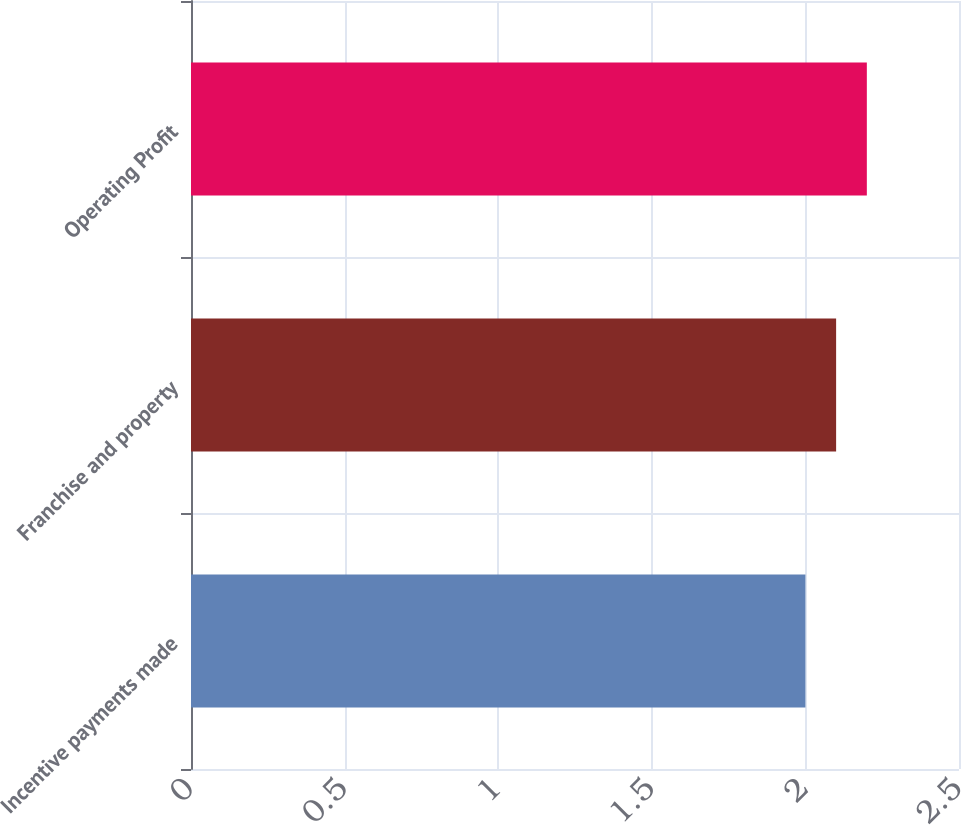Convert chart. <chart><loc_0><loc_0><loc_500><loc_500><bar_chart><fcel>Incentive payments made<fcel>Franchise and property<fcel>Operating Profit<nl><fcel>2<fcel>2.1<fcel>2.2<nl></chart> 